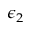<formula> <loc_0><loc_0><loc_500><loc_500>\epsilon _ { 2 }</formula> 